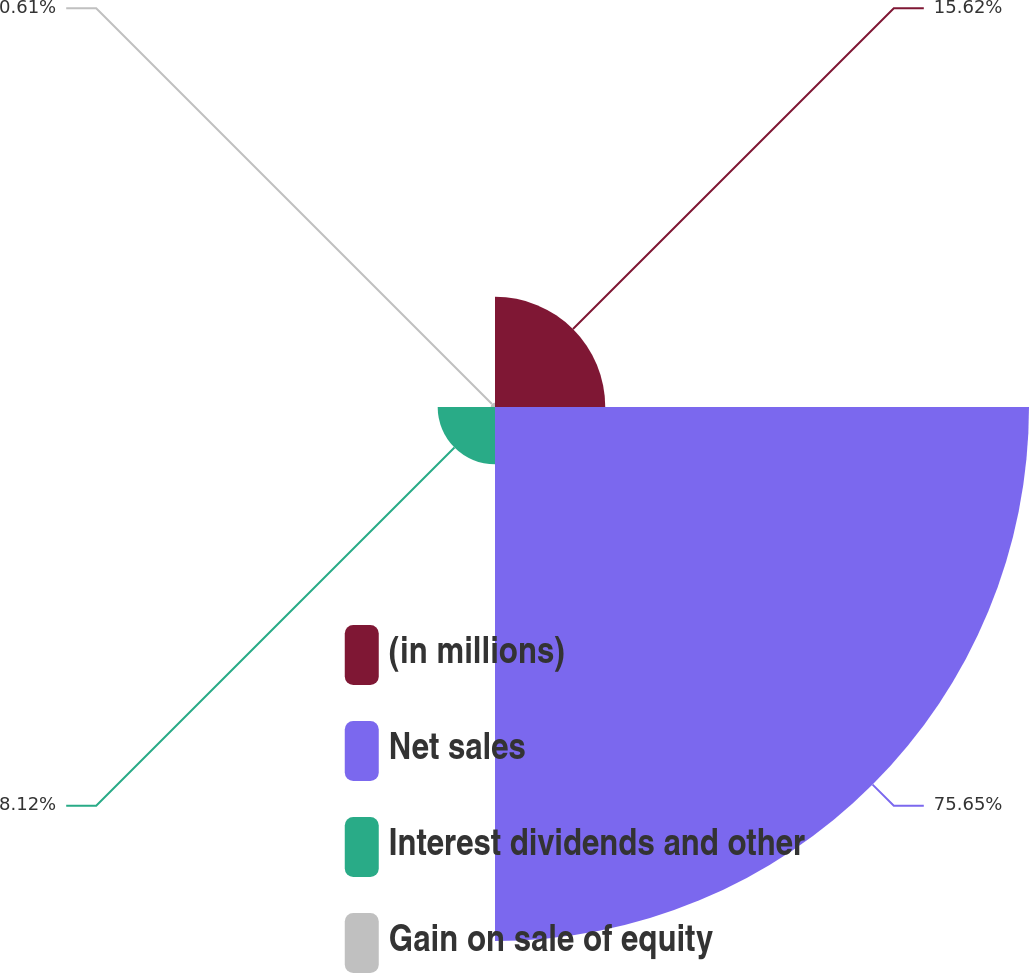Convert chart. <chart><loc_0><loc_0><loc_500><loc_500><pie_chart><fcel>(in millions)<fcel>Net sales<fcel>Interest dividends and other<fcel>Gain on sale of equity<nl><fcel>15.62%<fcel>75.65%<fcel>8.12%<fcel>0.61%<nl></chart> 